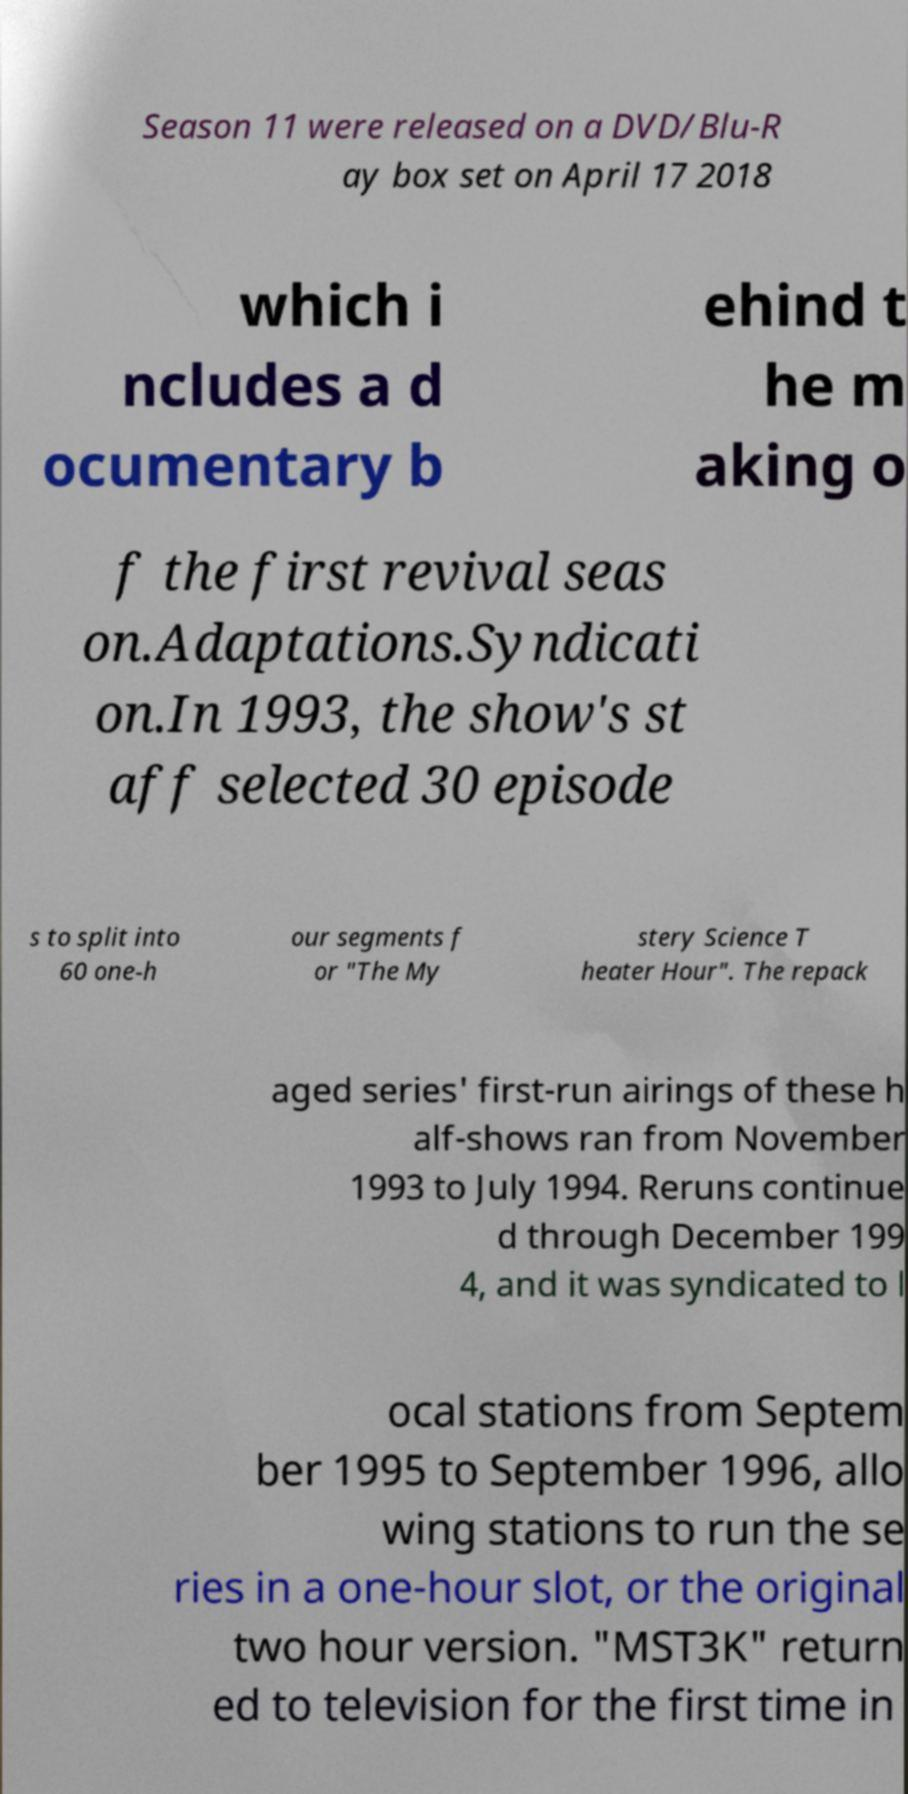Could you extract and type out the text from this image? Season 11 were released on a DVD/Blu-R ay box set on April 17 2018 which i ncludes a d ocumentary b ehind t he m aking o f the first revival seas on.Adaptations.Syndicati on.In 1993, the show's st aff selected 30 episode s to split into 60 one-h our segments f or "The My stery Science T heater Hour". The repack aged series' first-run airings of these h alf-shows ran from November 1993 to July 1994. Reruns continue d through December 199 4, and it was syndicated to l ocal stations from Septem ber 1995 to September 1996, allo wing stations to run the se ries in a one-hour slot, or the original two hour version. "MST3K" return ed to television for the first time in 